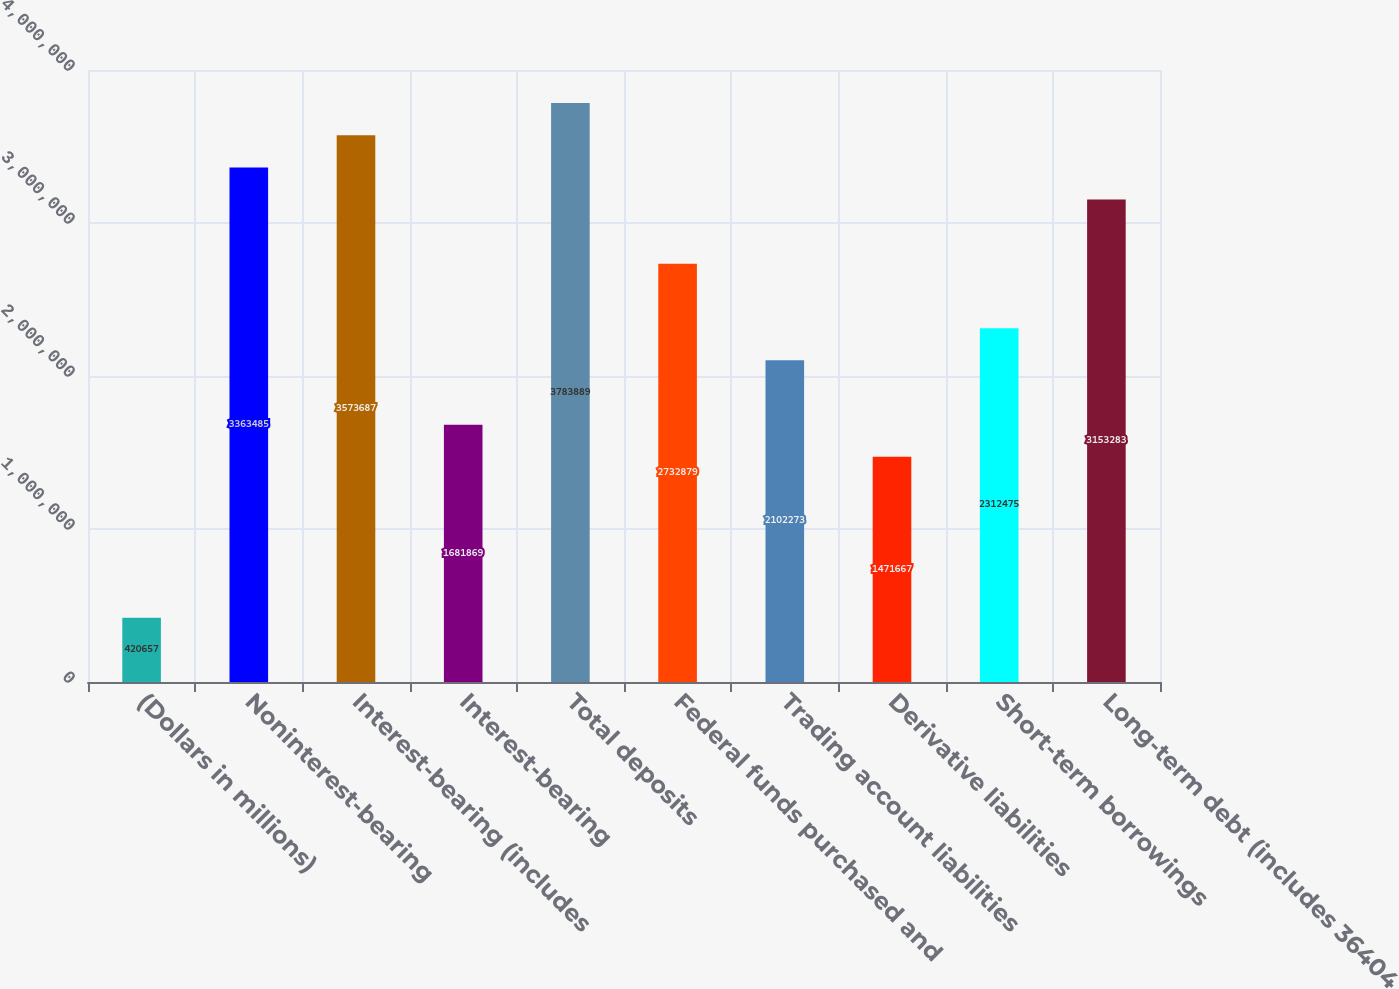Convert chart. <chart><loc_0><loc_0><loc_500><loc_500><bar_chart><fcel>(Dollars in millions)<fcel>Noninterest-bearing<fcel>Interest-bearing (includes<fcel>Interest-bearing<fcel>Total deposits<fcel>Federal funds purchased and<fcel>Trading account liabilities<fcel>Derivative liabilities<fcel>Short-term borrowings<fcel>Long-term debt (includes 36404<nl><fcel>420657<fcel>3.36348e+06<fcel>3.57369e+06<fcel>1.68187e+06<fcel>3.78389e+06<fcel>2.73288e+06<fcel>2.10227e+06<fcel>1.47167e+06<fcel>2.31248e+06<fcel>3.15328e+06<nl></chart> 